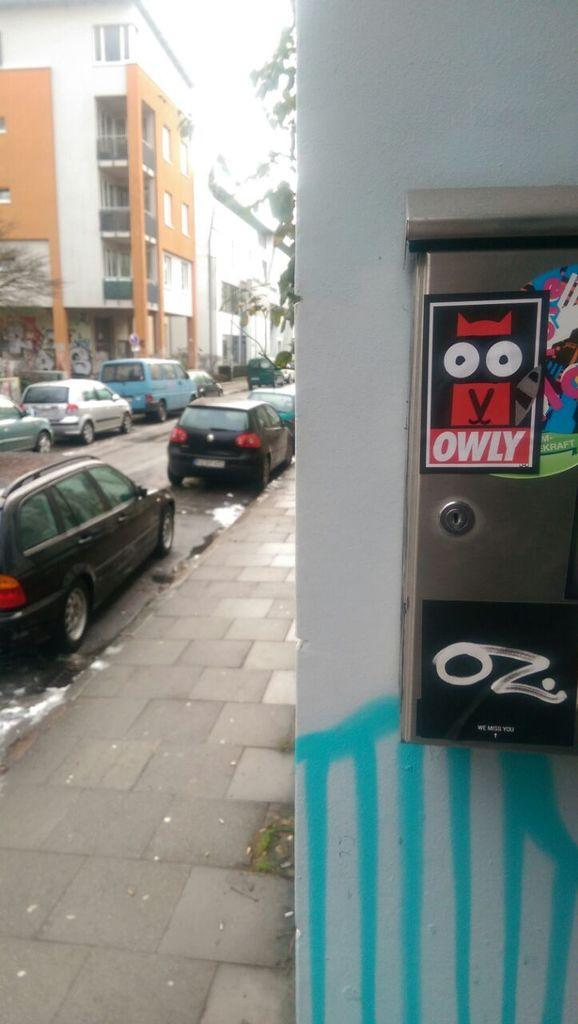What type of structures are present in the image? There are buildings in the image. What can be seen on the left side of the image? There are cars on the road on the left side of the image. What type of vegetation is visible in the background of the image? There are trees in the background of the image. What is visible in the background of the image besides the trees? The sky is visible in the background of the image. Can you tell me the birth date of the person who wrote the desire for a car in the image? There is no person or writing present in the image, so it is not possible to determine the birth date or the desire for a car. 